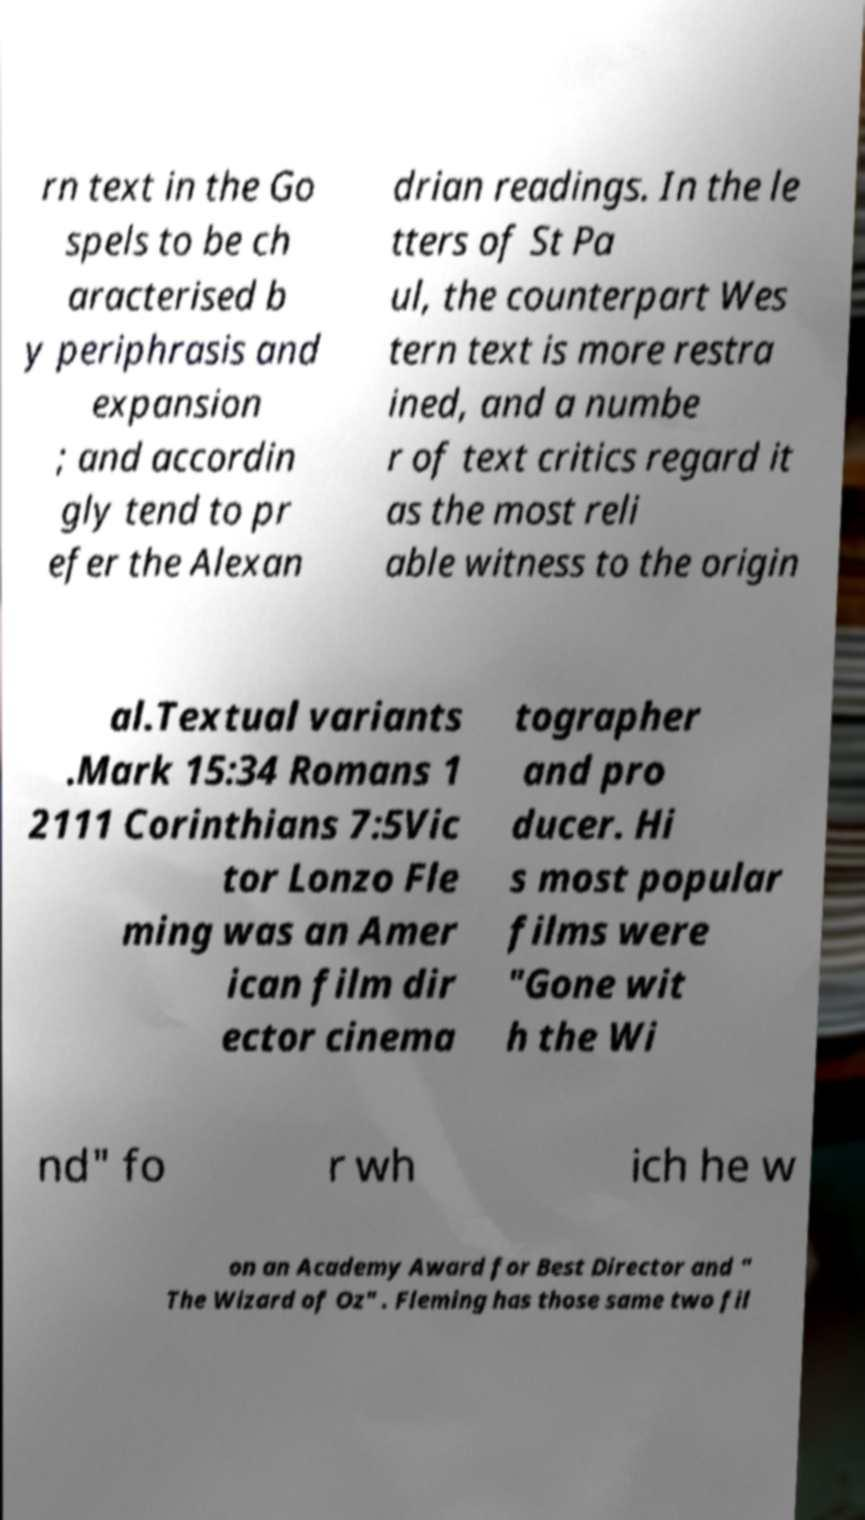I need the written content from this picture converted into text. Can you do that? rn text in the Go spels to be ch aracterised b y periphrasis and expansion ; and accordin gly tend to pr efer the Alexan drian readings. In the le tters of St Pa ul, the counterpart Wes tern text is more restra ined, and a numbe r of text critics regard it as the most reli able witness to the origin al.Textual variants .Mark 15:34 Romans 1 2111 Corinthians 7:5Vic tor Lonzo Fle ming was an Amer ican film dir ector cinema tographer and pro ducer. Hi s most popular films were "Gone wit h the Wi nd" fo r wh ich he w on an Academy Award for Best Director and " The Wizard of Oz" . Fleming has those same two fil 